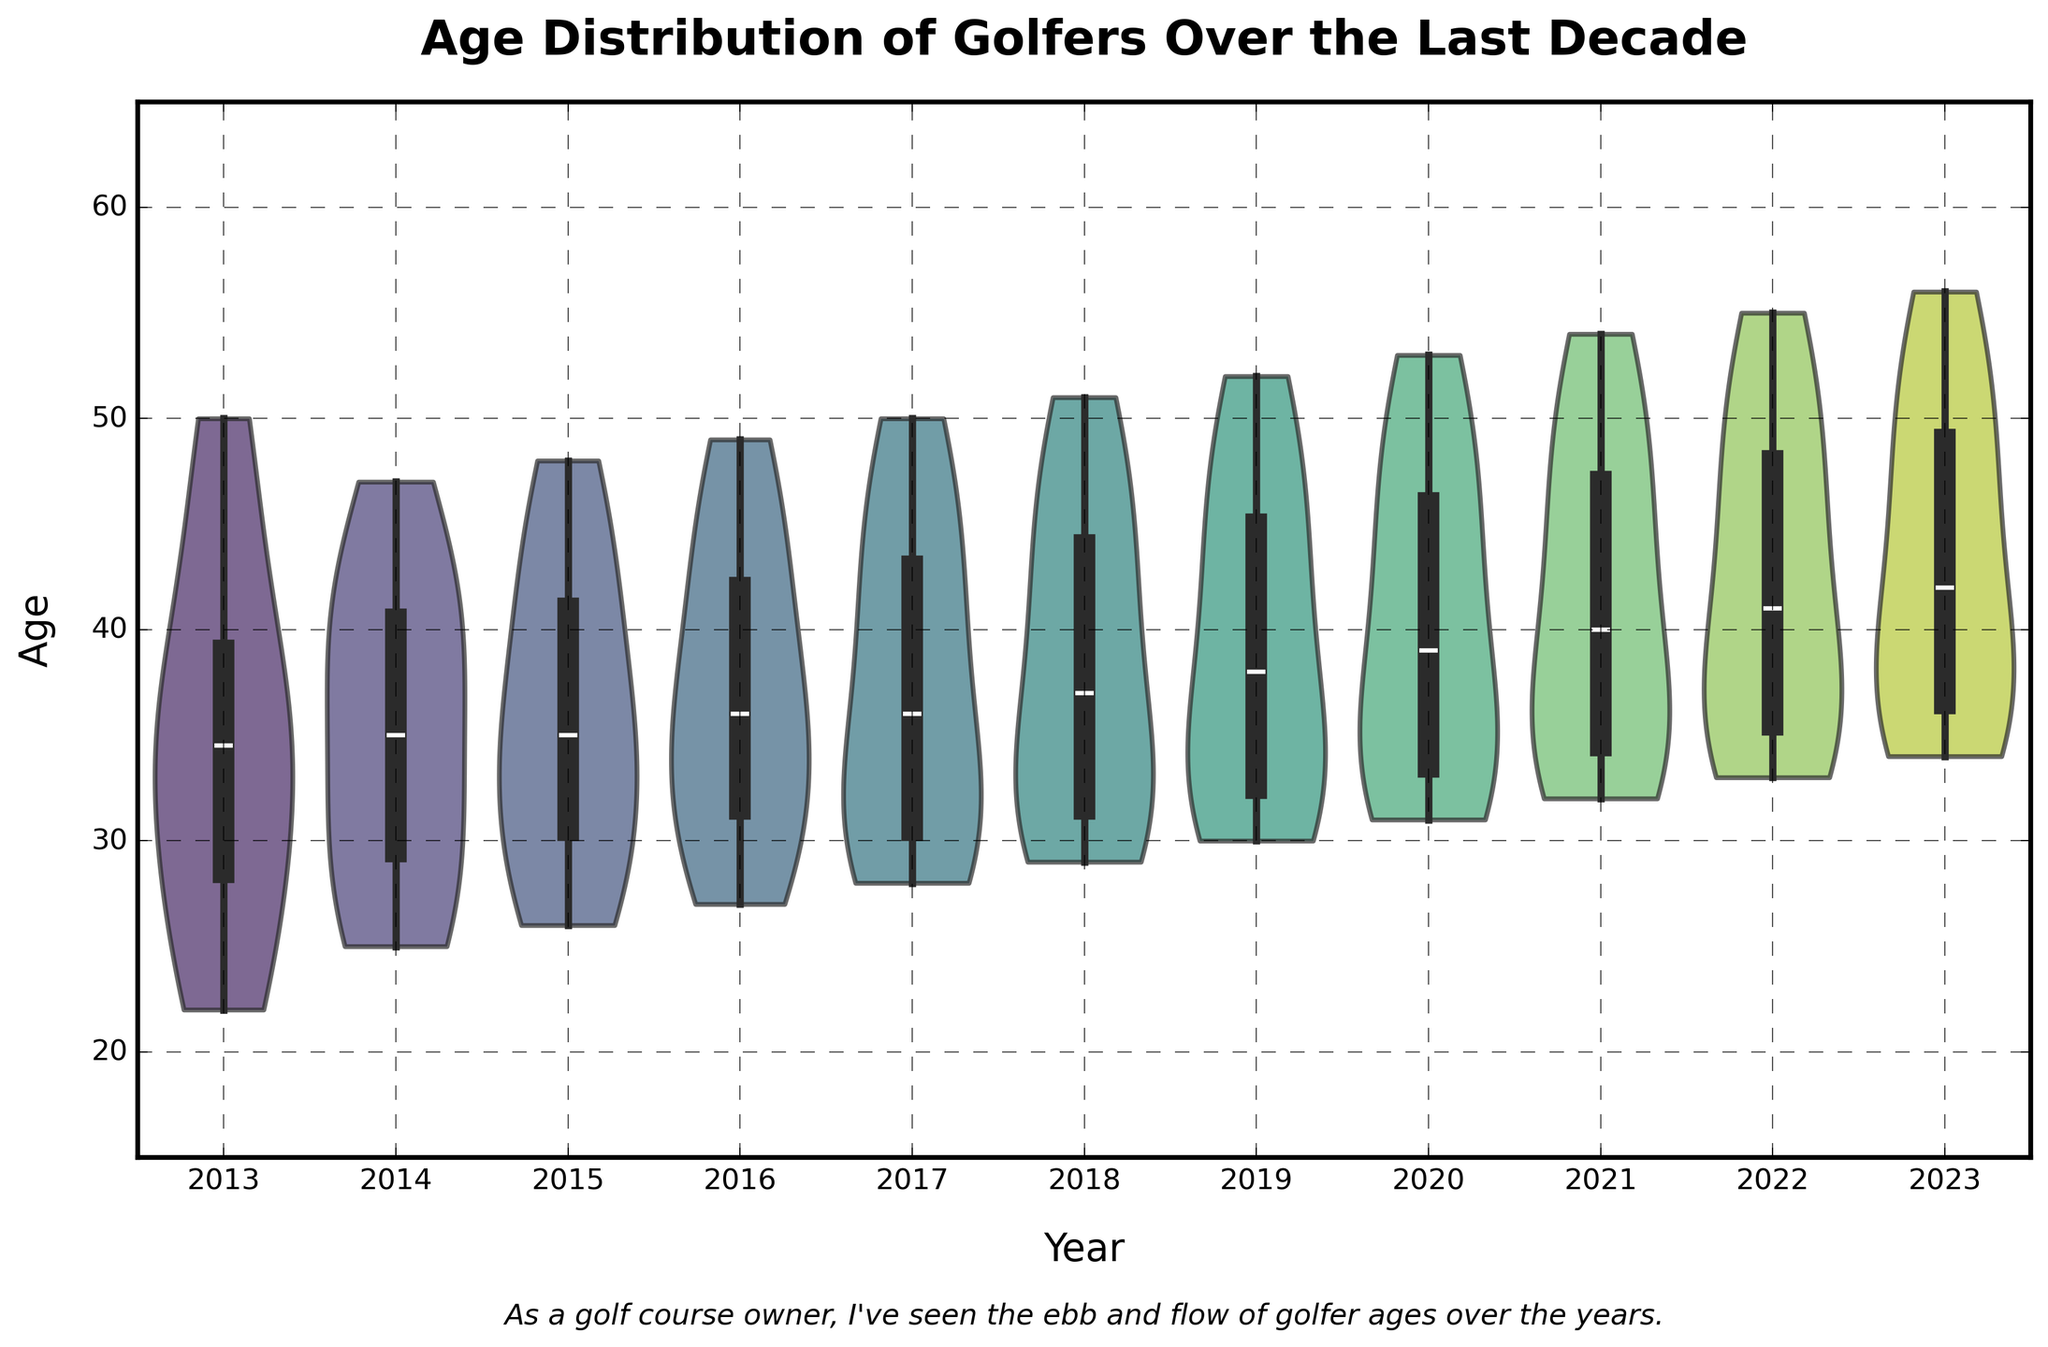What is the title of the figure? The title of the figure is located at the top center of the image and is written in bold, large font.
Answer: Age Distribution of Golfers Over the Last Decade What are the labels on the X and Y axes? The X axis label is at the bottom center of the chart and the Y axis label is on the left side. Both labels are in a clear, readable size.
Answer: Year (X axis); Age (Y axis) What is the range of the Y axis? The values on the Y axis range from the minimum to the maximum indicated by the ticks along the vertical axis. In this chart, it ranges from 15 to 65.
Answer: 15 to 65 In which year does the median age of golfers appear to be the highest? Observing the middle line inside the box of each violin plot represents the median. The median line is located highest in 2023.
Answer: 2023 How does the age distribution change over the years? By examining the width and shape of the violins, we can see how the density of ages varies year by year. Generally, as the years progress, the median age appears to increase, and the spread widens.
Answer: The median age increases over the years, and the age range widens Which year shows the widest range of age distribution? The range of the distribution is indicated by how tall the violin plot is. The plot with the most extended tips represents the widest range, evident in 2023.
Answer: 2023 In what year are the youngest and oldest golfers closest in age? By comparing the relative height of the violins, we can identify the closest age spread by looking at the shortest violin plot vertically. The closest ages are in 2013.
Answer: 2013 What age range is most common in 2017? In the 2017 violin plot, the bulkiest part of the violin represents the most common age range. This appears prominently around the early 30s to mid-30s.
Answer: early 30s to mid-30s What is the unique feature added to the violin plots in this chart to aid in interpretation? Each violin plot contains an overlaid box plot, which helps in identifying the median, quartiles, and potential outliers within the distribution.
Answer: Box Plot Overlay 